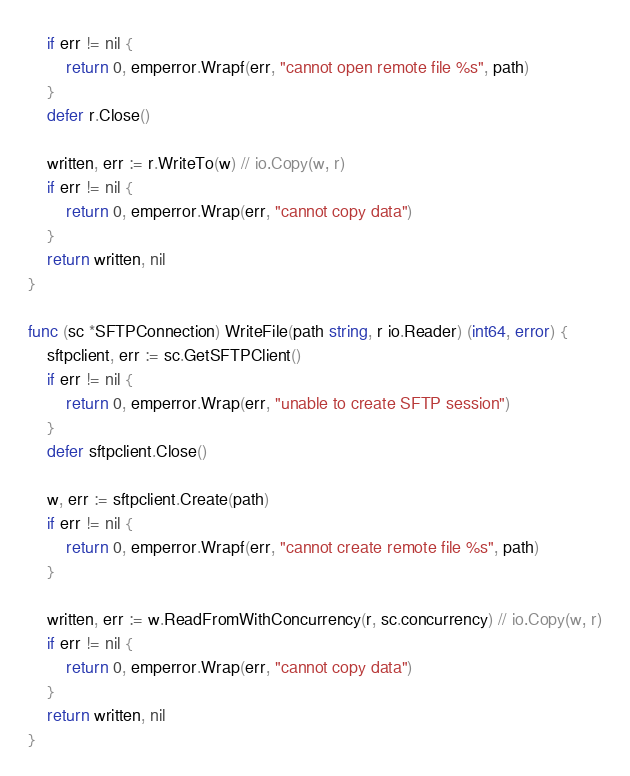Convert code to text. <code><loc_0><loc_0><loc_500><loc_500><_Go_>	if err != nil {
		return 0, emperror.Wrapf(err, "cannot open remote file %s", path)
	}
	defer r.Close()

	written, err := r.WriteTo(w) // io.Copy(w, r)
	if err != nil {
		return 0, emperror.Wrap(err, "cannot copy data")
	}
	return written, nil
}

func (sc *SFTPConnection) WriteFile(path string, r io.Reader) (int64, error) {
	sftpclient, err := sc.GetSFTPClient()
	if err != nil {
		return 0, emperror.Wrap(err, "unable to create SFTP session")
	}
	defer sftpclient.Close()

	w, err := sftpclient.Create(path)
	if err != nil {
		return 0, emperror.Wrapf(err, "cannot create remote file %s", path)
	}

	written, err := w.ReadFromWithConcurrency(r, sc.concurrency) // io.Copy(w, r)
	if err != nil {
		return 0, emperror.Wrap(err, "cannot copy data")
	}
	return written, nil
}
</code> 